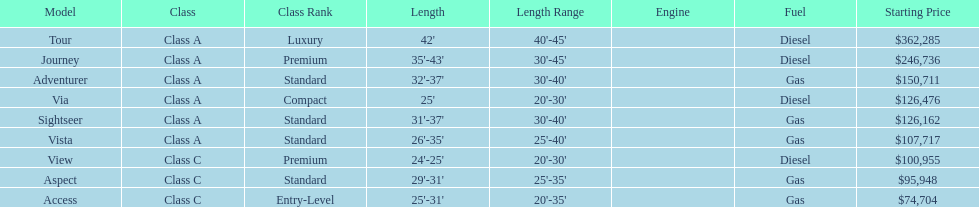What is the name of the top priced winnebago model? Tour. 